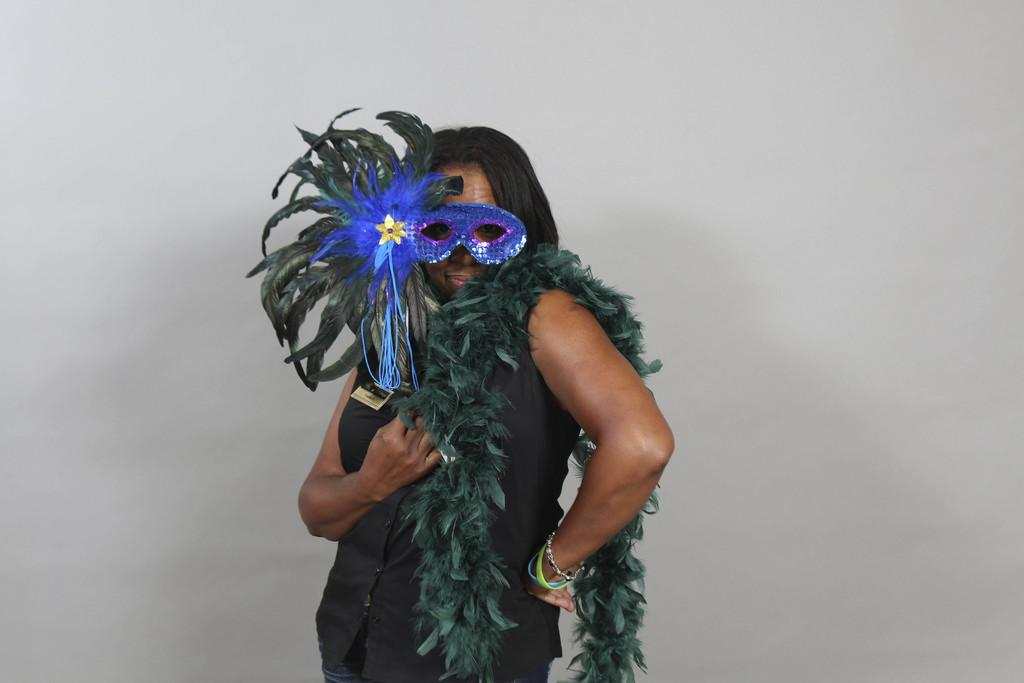What is the main subject of the image? There is a person in the image. What is the person holding in the image? The person is holding a costume. What is the person wearing in the image? The person is wearing a decorative item. What can be seen in the background of the image? There is a wall in the background of the image. What type of care does the dog in the image need? There is no dog present in the image, so it is not possible to determine the type of care it might need. 